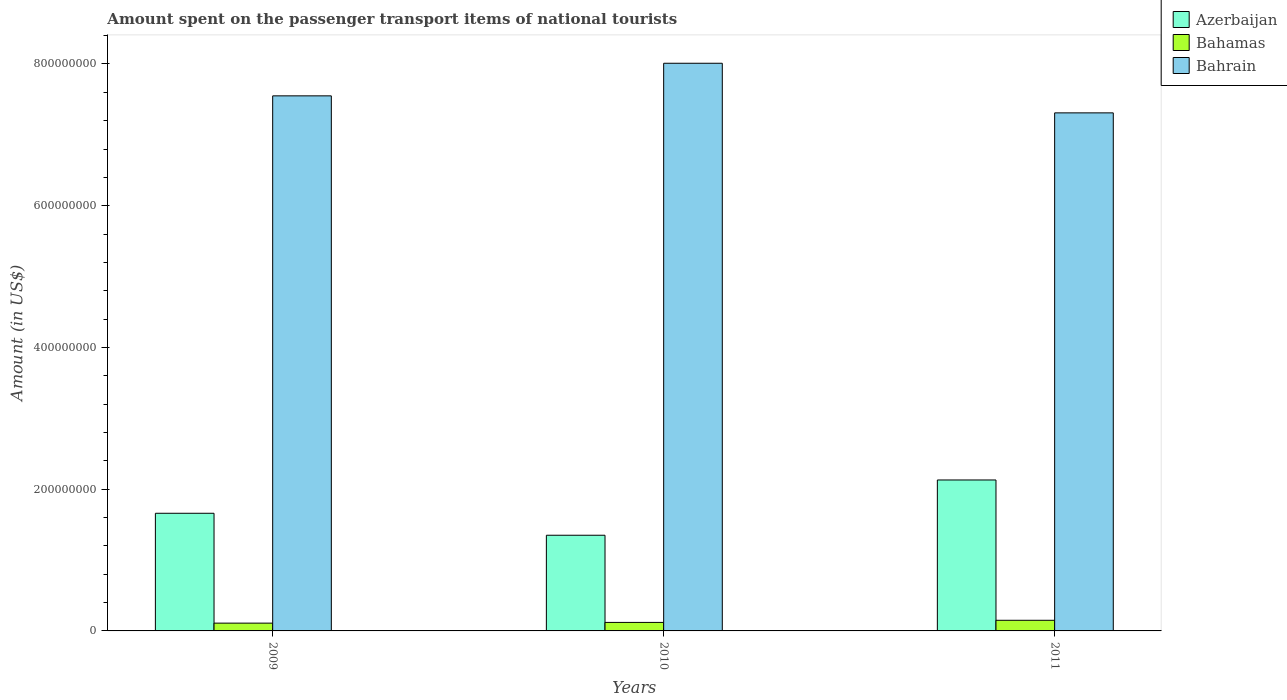How many groups of bars are there?
Your answer should be compact. 3. Are the number of bars on each tick of the X-axis equal?
Make the answer very short. Yes. What is the label of the 2nd group of bars from the left?
Keep it short and to the point. 2010. In how many cases, is the number of bars for a given year not equal to the number of legend labels?
Provide a short and direct response. 0. What is the amount spent on the passenger transport items of national tourists in Azerbaijan in 2011?
Provide a short and direct response. 2.13e+08. Across all years, what is the maximum amount spent on the passenger transport items of national tourists in Azerbaijan?
Make the answer very short. 2.13e+08. Across all years, what is the minimum amount spent on the passenger transport items of national tourists in Bahamas?
Your response must be concise. 1.10e+07. In which year was the amount spent on the passenger transport items of national tourists in Bahamas maximum?
Make the answer very short. 2011. What is the total amount spent on the passenger transport items of national tourists in Bahamas in the graph?
Keep it short and to the point. 3.80e+07. What is the difference between the amount spent on the passenger transport items of national tourists in Bahamas in 2009 and that in 2010?
Your answer should be compact. -1.00e+06. What is the difference between the amount spent on the passenger transport items of national tourists in Bahamas in 2011 and the amount spent on the passenger transport items of national tourists in Azerbaijan in 2010?
Keep it short and to the point. -1.20e+08. What is the average amount spent on the passenger transport items of national tourists in Azerbaijan per year?
Ensure brevity in your answer.  1.71e+08. In the year 2010, what is the difference between the amount spent on the passenger transport items of national tourists in Bahamas and amount spent on the passenger transport items of national tourists in Azerbaijan?
Your response must be concise. -1.23e+08. In how many years, is the amount spent on the passenger transport items of national tourists in Bahrain greater than 400000000 US$?
Your response must be concise. 3. What is the ratio of the amount spent on the passenger transport items of national tourists in Azerbaijan in 2010 to that in 2011?
Provide a succinct answer. 0.63. What is the difference between the highest and the second highest amount spent on the passenger transport items of national tourists in Bahamas?
Offer a very short reply. 3.00e+06. What is the difference between the highest and the lowest amount spent on the passenger transport items of national tourists in Azerbaijan?
Provide a succinct answer. 7.80e+07. Is the sum of the amount spent on the passenger transport items of national tourists in Bahamas in 2010 and 2011 greater than the maximum amount spent on the passenger transport items of national tourists in Bahrain across all years?
Give a very brief answer. No. What does the 3rd bar from the left in 2009 represents?
Your answer should be compact. Bahrain. What does the 3rd bar from the right in 2009 represents?
Give a very brief answer. Azerbaijan. Are all the bars in the graph horizontal?
Give a very brief answer. No. How many years are there in the graph?
Your answer should be compact. 3. What is the difference between two consecutive major ticks on the Y-axis?
Provide a short and direct response. 2.00e+08. Are the values on the major ticks of Y-axis written in scientific E-notation?
Your answer should be compact. No. What is the title of the graph?
Offer a very short reply. Amount spent on the passenger transport items of national tourists. What is the label or title of the X-axis?
Provide a succinct answer. Years. What is the Amount (in US$) of Azerbaijan in 2009?
Provide a short and direct response. 1.66e+08. What is the Amount (in US$) in Bahamas in 2009?
Keep it short and to the point. 1.10e+07. What is the Amount (in US$) in Bahrain in 2009?
Make the answer very short. 7.55e+08. What is the Amount (in US$) in Azerbaijan in 2010?
Keep it short and to the point. 1.35e+08. What is the Amount (in US$) of Bahamas in 2010?
Your answer should be very brief. 1.20e+07. What is the Amount (in US$) of Bahrain in 2010?
Offer a terse response. 8.01e+08. What is the Amount (in US$) in Azerbaijan in 2011?
Your response must be concise. 2.13e+08. What is the Amount (in US$) in Bahamas in 2011?
Offer a very short reply. 1.50e+07. What is the Amount (in US$) of Bahrain in 2011?
Your answer should be very brief. 7.31e+08. Across all years, what is the maximum Amount (in US$) of Azerbaijan?
Offer a terse response. 2.13e+08. Across all years, what is the maximum Amount (in US$) of Bahamas?
Ensure brevity in your answer.  1.50e+07. Across all years, what is the maximum Amount (in US$) of Bahrain?
Provide a short and direct response. 8.01e+08. Across all years, what is the minimum Amount (in US$) in Azerbaijan?
Provide a short and direct response. 1.35e+08. Across all years, what is the minimum Amount (in US$) in Bahamas?
Ensure brevity in your answer.  1.10e+07. Across all years, what is the minimum Amount (in US$) in Bahrain?
Keep it short and to the point. 7.31e+08. What is the total Amount (in US$) of Azerbaijan in the graph?
Your response must be concise. 5.14e+08. What is the total Amount (in US$) in Bahamas in the graph?
Offer a terse response. 3.80e+07. What is the total Amount (in US$) of Bahrain in the graph?
Your answer should be compact. 2.29e+09. What is the difference between the Amount (in US$) in Azerbaijan in 2009 and that in 2010?
Provide a short and direct response. 3.10e+07. What is the difference between the Amount (in US$) in Bahrain in 2009 and that in 2010?
Your answer should be compact. -4.60e+07. What is the difference between the Amount (in US$) of Azerbaijan in 2009 and that in 2011?
Give a very brief answer. -4.70e+07. What is the difference between the Amount (in US$) of Bahrain in 2009 and that in 2011?
Your answer should be very brief. 2.40e+07. What is the difference between the Amount (in US$) in Azerbaijan in 2010 and that in 2011?
Provide a succinct answer. -7.80e+07. What is the difference between the Amount (in US$) of Bahrain in 2010 and that in 2011?
Offer a very short reply. 7.00e+07. What is the difference between the Amount (in US$) of Azerbaijan in 2009 and the Amount (in US$) of Bahamas in 2010?
Offer a terse response. 1.54e+08. What is the difference between the Amount (in US$) of Azerbaijan in 2009 and the Amount (in US$) of Bahrain in 2010?
Ensure brevity in your answer.  -6.35e+08. What is the difference between the Amount (in US$) in Bahamas in 2009 and the Amount (in US$) in Bahrain in 2010?
Your response must be concise. -7.90e+08. What is the difference between the Amount (in US$) in Azerbaijan in 2009 and the Amount (in US$) in Bahamas in 2011?
Offer a terse response. 1.51e+08. What is the difference between the Amount (in US$) of Azerbaijan in 2009 and the Amount (in US$) of Bahrain in 2011?
Keep it short and to the point. -5.65e+08. What is the difference between the Amount (in US$) of Bahamas in 2009 and the Amount (in US$) of Bahrain in 2011?
Ensure brevity in your answer.  -7.20e+08. What is the difference between the Amount (in US$) in Azerbaijan in 2010 and the Amount (in US$) in Bahamas in 2011?
Make the answer very short. 1.20e+08. What is the difference between the Amount (in US$) of Azerbaijan in 2010 and the Amount (in US$) of Bahrain in 2011?
Your answer should be very brief. -5.96e+08. What is the difference between the Amount (in US$) in Bahamas in 2010 and the Amount (in US$) in Bahrain in 2011?
Provide a short and direct response. -7.19e+08. What is the average Amount (in US$) of Azerbaijan per year?
Your answer should be compact. 1.71e+08. What is the average Amount (in US$) in Bahamas per year?
Offer a very short reply. 1.27e+07. What is the average Amount (in US$) of Bahrain per year?
Provide a short and direct response. 7.62e+08. In the year 2009, what is the difference between the Amount (in US$) of Azerbaijan and Amount (in US$) of Bahamas?
Your answer should be compact. 1.55e+08. In the year 2009, what is the difference between the Amount (in US$) of Azerbaijan and Amount (in US$) of Bahrain?
Give a very brief answer. -5.89e+08. In the year 2009, what is the difference between the Amount (in US$) of Bahamas and Amount (in US$) of Bahrain?
Ensure brevity in your answer.  -7.44e+08. In the year 2010, what is the difference between the Amount (in US$) in Azerbaijan and Amount (in US$) in Bahamas?
Your answer should be very brief. 1.23e+08. In the year 2010, what is the difference between the Amount (in US$) of Azerbaijan and Amount (in US$) of Bahrain?
Ensure brevity in your answer.  -6.66e+08. In the year 2010, what is the difference between the Amount (in US$) in Bahamas and Amount (in US$) in Bahrain?
Your answer should be very brief. -7.89e+08. In the year 2011, what is the difference between the Amount (in US$) in Azerbaijan and Amount (in US$) in Bahamas?
Your answer should be compact. 1.98e+08. In the year 2011, what is the difference between the Amount (in US$) in Azerbaijan and Amount (in US$) in Bahrain?
Your answer should be very brief. -5.18e+08. In the year 2011, what is the difference between the Amount (in US$) of Bahamas and Amount (in US$) of Bahrain?
Offer a terse response. -7.16e+08. What is the ratio of the Amount (in US$) in Azerbaijan in 2009 to that in 2010?
Give a very brief answer. 1.23. What is the ratio of the Amount (in US$) in Bahamas in 2009 to that in 2010?
Give a very brief answer. 0.92. What is the ratio of the Amount (in US$) in Bahrain in 2009 to that in 2010?
Offer a very short reply. 0.94. What is the ratio of the Amount (in US$) in Azerbaijan in 2009 to that in 2011?
Give a very brief answer. 0.78. What is the ratio of the Amount (in US$) in Bahamas in 2009 to that in 2011?
Offer a terse response. 0.73. What is the ratio of the Amount (in US$) in Bahrain in 2009 to that in 2011?
Your response must be concise. 1.03. What is the ratio of the Amount (in US$) in Azerbaijan in 2010 to that in 2011?
Give a very brief answer. 0.63. What is the ratio of the Amount (in US$) in Bahamas in 2010 to that in 2011?
Keep it short and to the point. 0.8. What is the ratio of the Amount (in US$) of Bahrain in 2010 to that in 2011?
Make the answer very short. 1.1. What is the difference between the highest and the second highest Amount (in US$) in Azerbaijan?
Give a very brief answer. 4.70e+07. What is the difference between the highest and the second highest Amount (in US$) of Bahamas?
Provide a short and direct response. 3.00e+06. What is the difference between the highest and the second highest Amount (in US$) in Bahrain?
Your response must be concise. 4.60e+07. What is the difference between the highest and the lowest Amount (in US$) of Azerbaijan?
Your response must be concise. 7.80e+07. What is the difference between the highest and the lowest Amount (in US$) of Bahamas?
Offer a very short reply. 4.00e+06. What is the difference between the highest and the lowest Amount (in US$) in Bahrain?
Provide a succinct answer. 7.00e+07. 